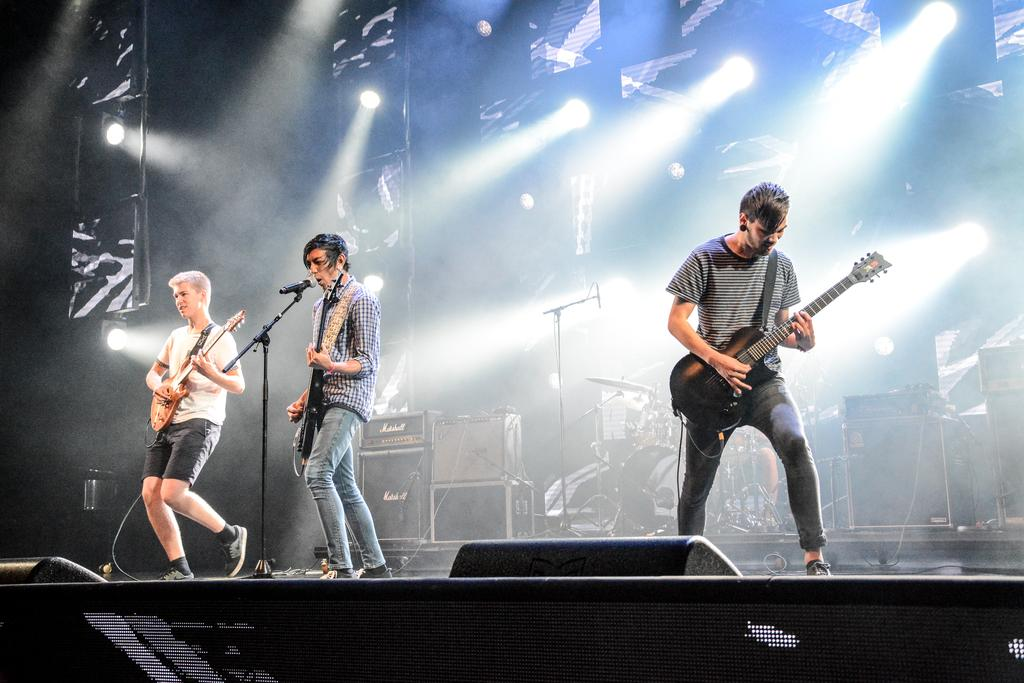What are the three men in the image doing? The three men are playing guitar in the image. Is there anyone else performing with them? Yes, there is a man singing with the help of a microphone. What instrument is being played in the background? There is a man playing drums in the background. What type of creature is crawling on the stomach of the man playing drums? There is no creature crawling on the stomach of the man playing drums in the image. 